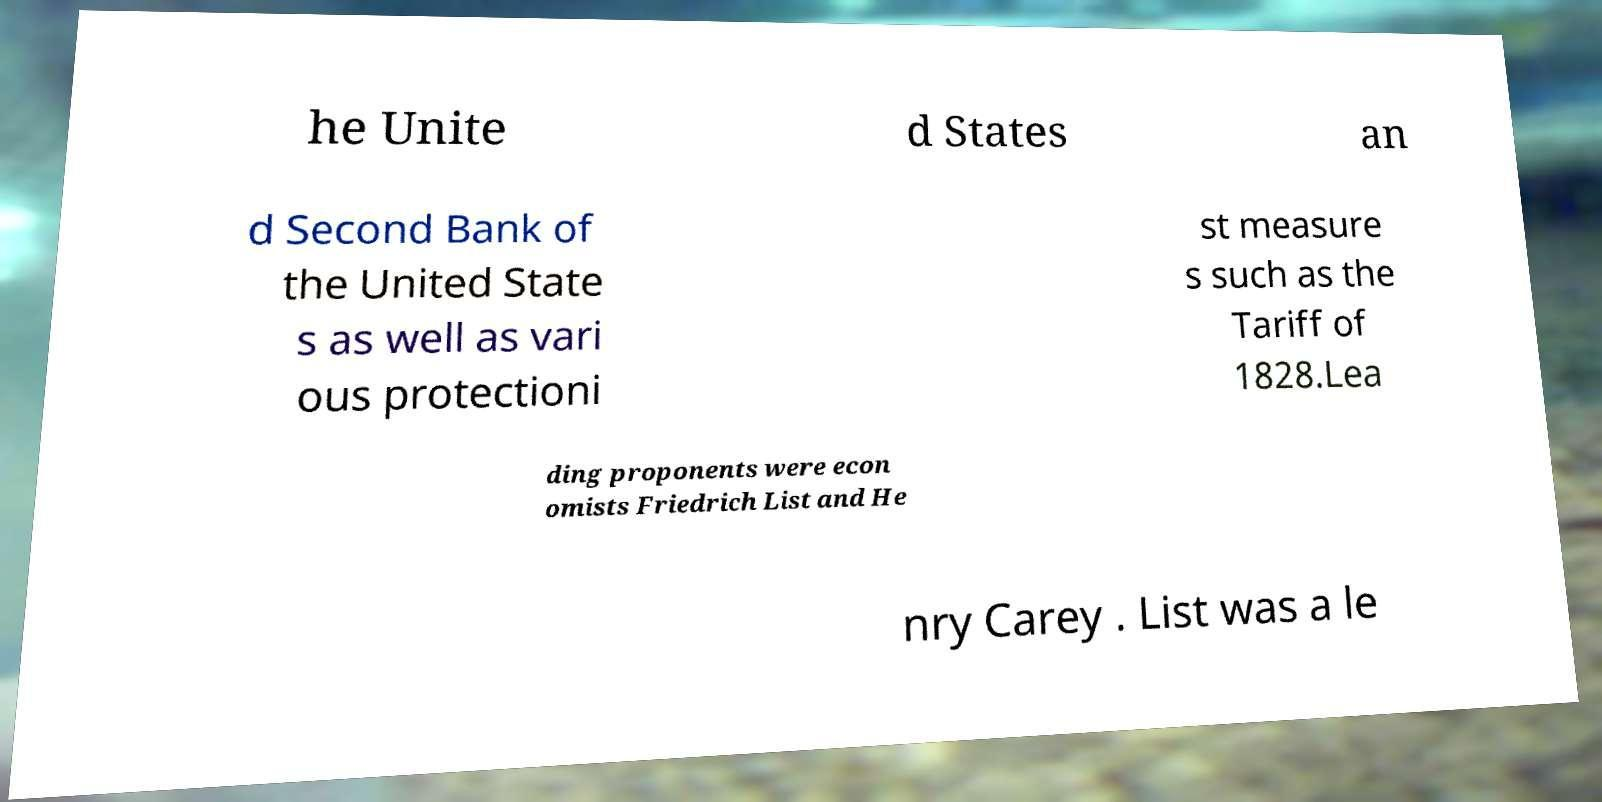For documentation purposes, I need the text within this image transcribed. Could you provide that? he Unite d States an d Second Bank of the United State s as well as vari ous protectioni st measure s such as the Tariff of 1828.Lea ding proponents were econ omists Friedrich List and He nry Carey . List was a le 